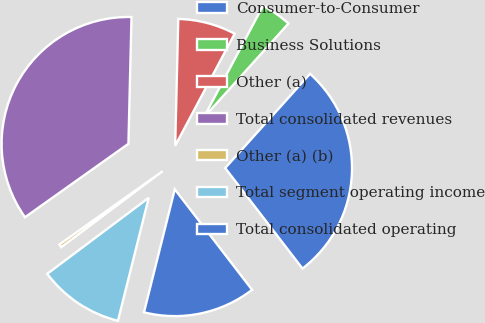Convert chart to OTSL. <chart><loc_0><loc_0><loc_500><loc_500><pie_chart><fcel>Consumer-to-Consumer<fcel>Business Solutions<fcel>Other (a)<fcel>Total consolidated revenues<fcel>Other (a) (b)<fcel>Total segment operating income<fcel>Total consolidated operating<nl><fcel>27.9%<fcel>3.9%<fcel>7.38%<fcel>35.22%<fcel>0.41%<fcel>10.86%<fcel>14.34%<nl></chart> 